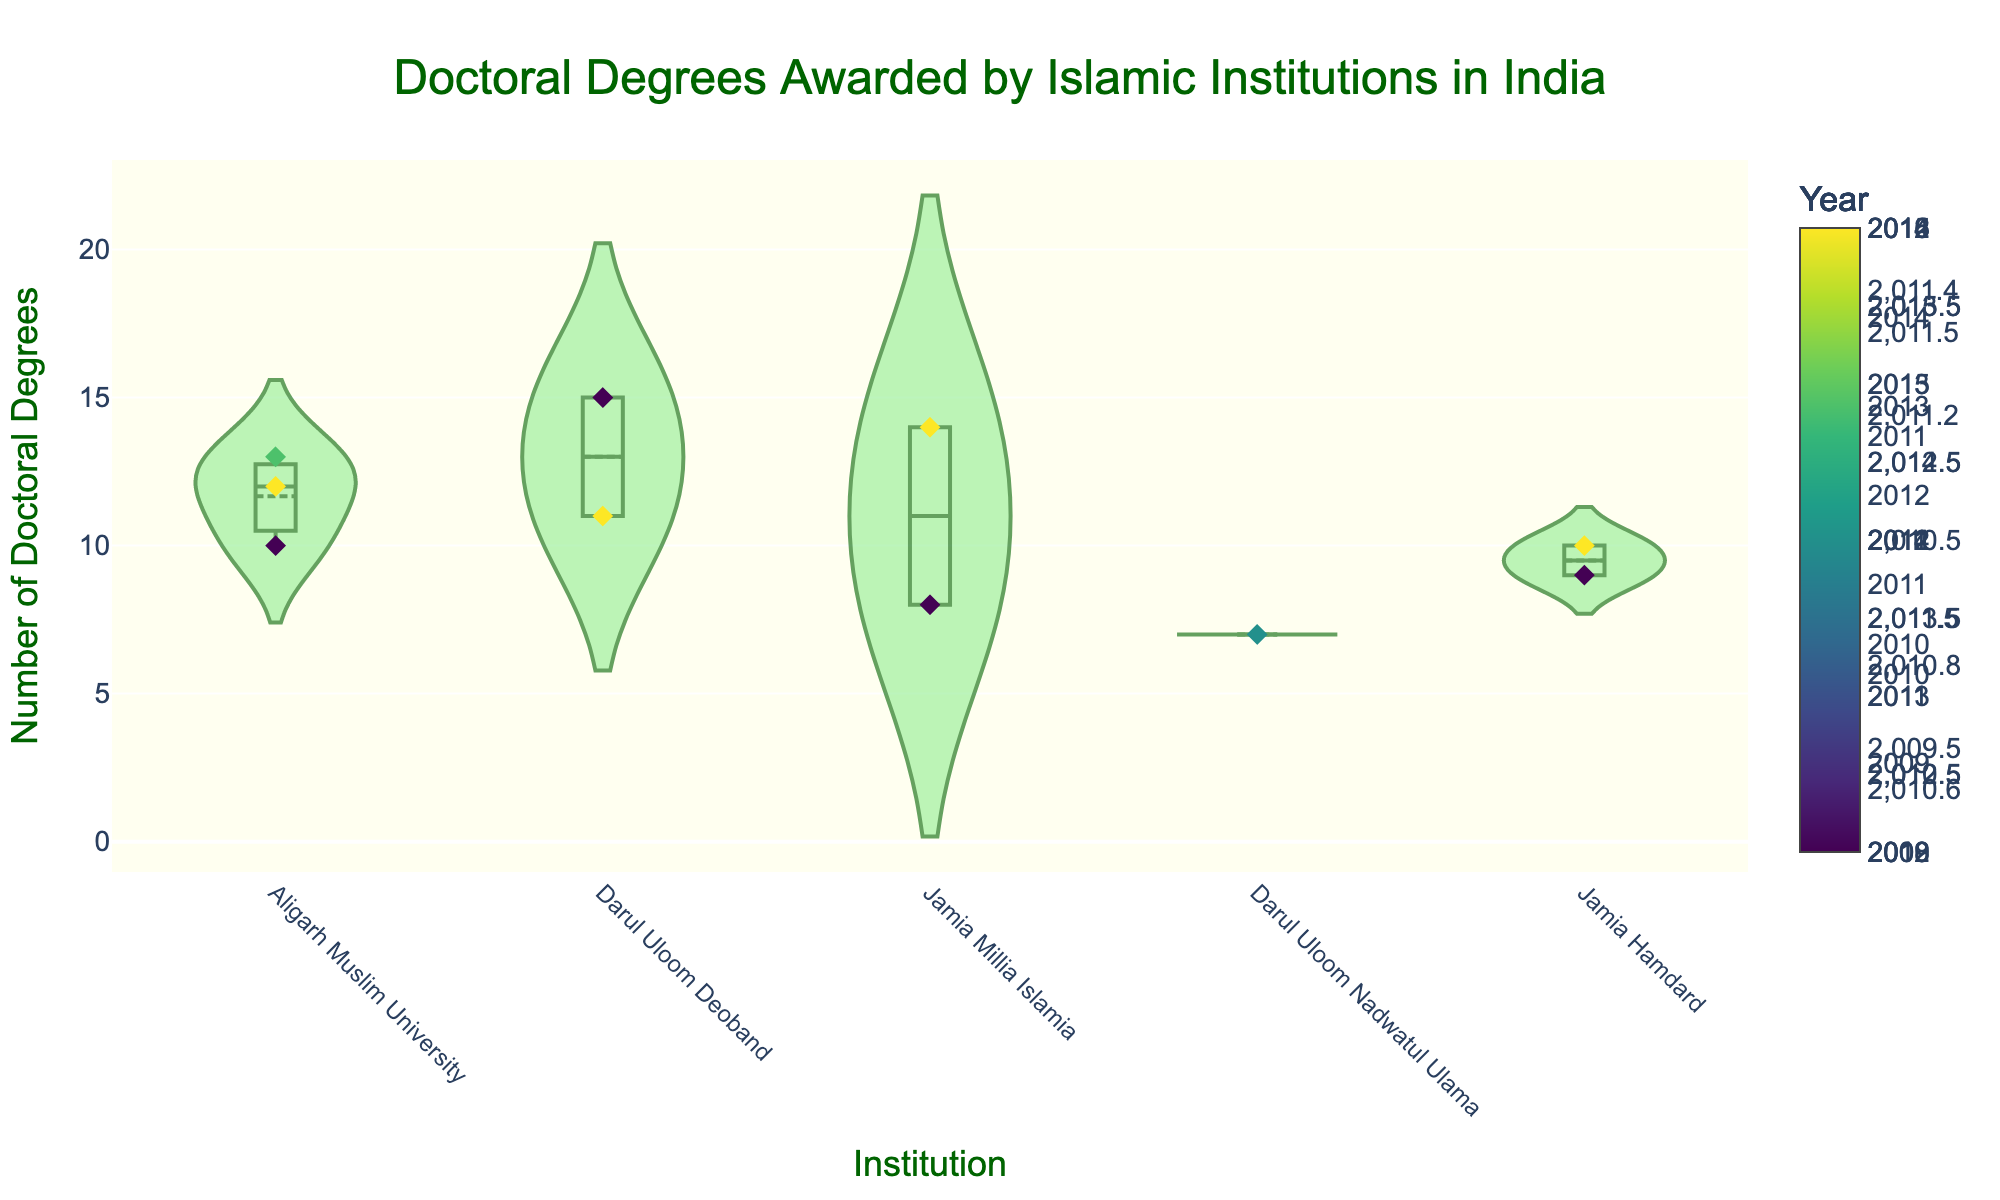How many institutions are represented in the chart? The chart has separate violin plots for each institution. Counting these violins will give the number of institutions.
Answer: 4 Which institution awarded the most doctoral degrees in a single year? The highest value within a violin plot indicates the maximum number of doctoral degrees awarded by that institution in any given year.
Answer: Darul Uloom Deoband What is the average number of doctoral degrees awarded by Jamia Millia Islamia? The average can be found by summing the values within the violin plot of Jamia Millia Islamia and dividing by the number of data points. Specifically: (8 + 14) / 2 = 11.
Answer: 11 Which institution shows the widest range of doctoral degrees awarded? The range is indicated by the spread of the violin plots from top to bottom. The wider the spread, the larger the range.
Answer: Darul Uloom Deoband What is the median number of doctoral degrees awarded by Aligarh Muslim University? The median is the middle value when the numbers are sorted. For Aligarh Muslim University: 10, 12, 13; the median is the middle one.
Answer: 12 In which year did Jamia Hamdard award the most doctoral degrees? By looking at the color-coded jittered points within Jamia Hamdard's violin plot and identifying the point with the highest value.
Answer: 2012 Compare the number of doctoral degrees awarded by Aligarh Muslim University and Darul Uloom Nadwatul Ulama. Which institution awarded more? By examining the meanlines or the median values within the violin plots of both institutions.
Answer: Aligarh Muslim University Which institution has the most consistent number of doctoral degrees awarded (least variability)? The consistency is indicated by the tightness or less spread in the violin plot. The less spread, the more consistent the data.
Answer: Darul Uloom Nadwatul Ulama What is the trend of doctoral degrees awarded by Darul Uloom Deoband over the years? Analyze the color gradient of the jittered points within Darul Uloom Deoband's violin plot.
Answer: Increasing trend 